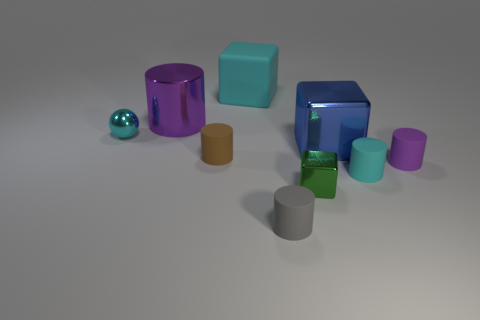Add 1 big blue cubes. How many objects exist? 10 Subtract all brown rubber cylinders. How many cylinders are left? 4 Subtract all gray cylinders. How many cylinders are left? 4 Subtract 0 red cylinders. How many objects are left? 9 Subtract all cylinders. How many objects are left? 4 Subtract 1 cubes. How many cubes are left? 2 Subtract all gray blocks. Subtract all blue spheres. How many blocks are left? 3 Subtract all gray cylinders. How many blue cubes are left? 1 Subtract all green objects. Subtract all tiny gray cylinders. How many objects are left? 7 Add 6 small purple rubber cylinders. How many small purple rubber cylinders are left? 7 